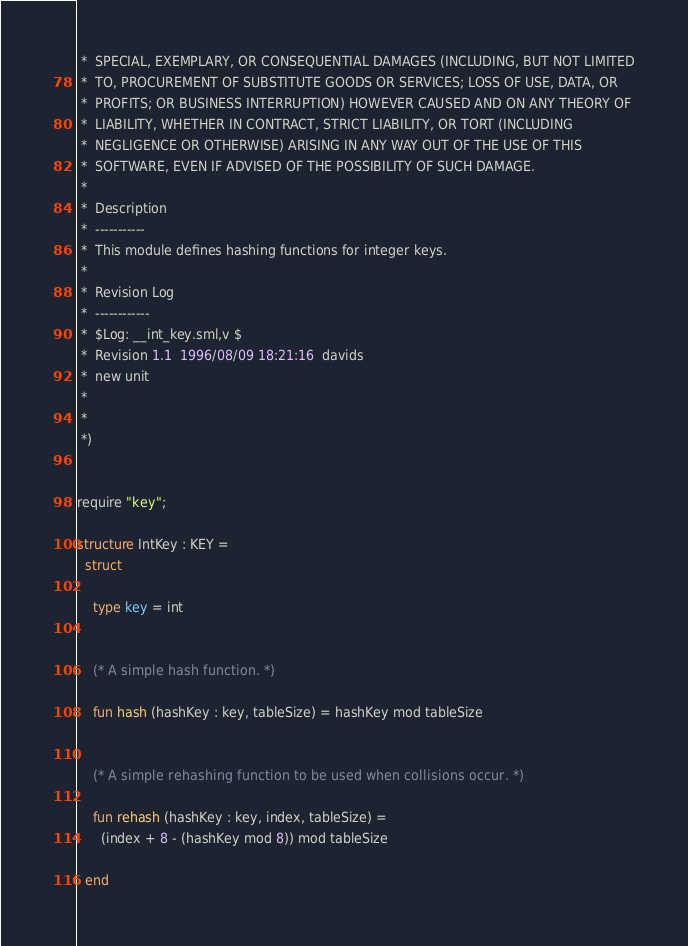<code> <loc_0><loc_0><loc_500><loc_500><_SML_> *  SPECIAL, EXEMPLARY, OR CONSEQUENTIAL DAMAGES (INCLUDING, BUT NOT LIMITED
 *  TO, PROCUREMENT OF SUBSTITUTE GOODS OR SERVICES; LOSS OF USE, DATA, OR
 *  PROFITS; OR BUSINESS INTERRUPTION) HOWEVER CAUSED AND ON ANY THEORY OF
 *  LIABILITY, WHETHER IN CONTRACT, STRICT LIABILITY, OR TORT (INCLUDING
 *  NEGLIGENCE OR OTHERWISE) ARISING IN ANY WAY OUT OF THE USE OF THIS
 *  SOFTWARE, EVEN IF ADVISED OF THE POSSIBILITY OF SUCH DAMAGE.
 *
 *  Description
 *  -----------
 *  This module defines hashing functions for integer keys.
 *
 *  Revision Log
 *  ------------
 *  $Log: __int_key.sml,v $
 *  Revision 1.1  1996/08/09 18:21:16  davids
 *  new unit
 *
 *
 *)


require "key";

structure IntKey : KEY =
  struct

    type key = int


    (* A simple hash function. *)

    fun hash (hashKey : key, tableSize) = hashKey mod tableSize


    (* A simple rehashing function to be used when collisions occur. *)

    fun rehash (hashKey : key, index, tableSize) = 
      (index + 8 - (hashKey mod 8)) mod tableSize

  end

</code> 